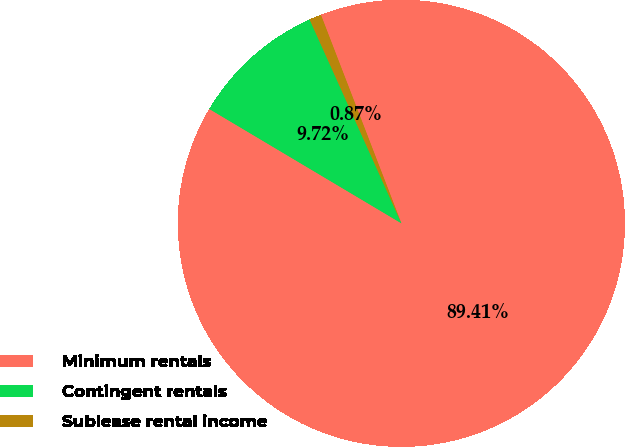Convert chart to OTSL. <chart><loc_0><loc_0><loc_500><loc_500><pie_chart><fcel>Minimum rentals<fcel>Contingent rentals<fcel>Sublease rental income<nl><fcel>89.41%<fcel>9.72%<fcel>0.87%<nl></chart> 